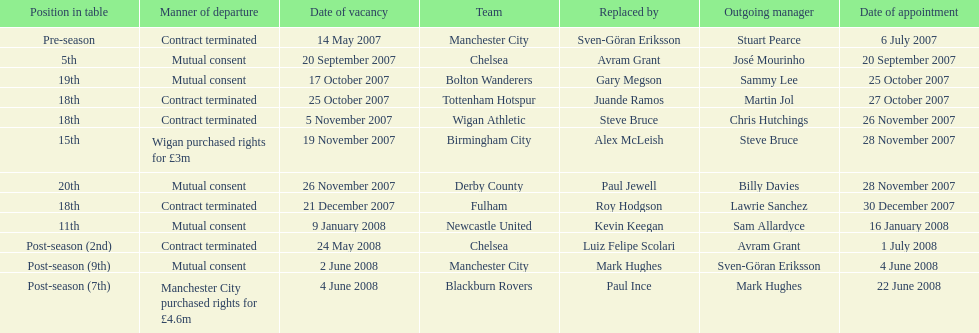Avram grant was with chelsea for at least how many years? 1. 